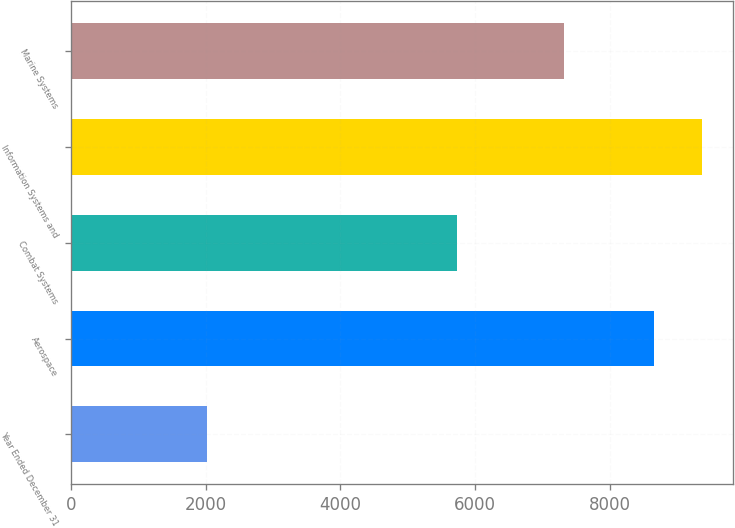Convert chart to OTSL. <chart><loc_0><loc_0><loc_500><loc_500><bar_chart><fcel>Year Ended December 31<fcel>Aerospace<fcel>Combat Systems<fcel>Information Systems and<fcel>Marine Systems<nl><fcel>2014<fcel>8649<fcel>5732<fcel>9363.5<fcel>7312<nl></chart> 